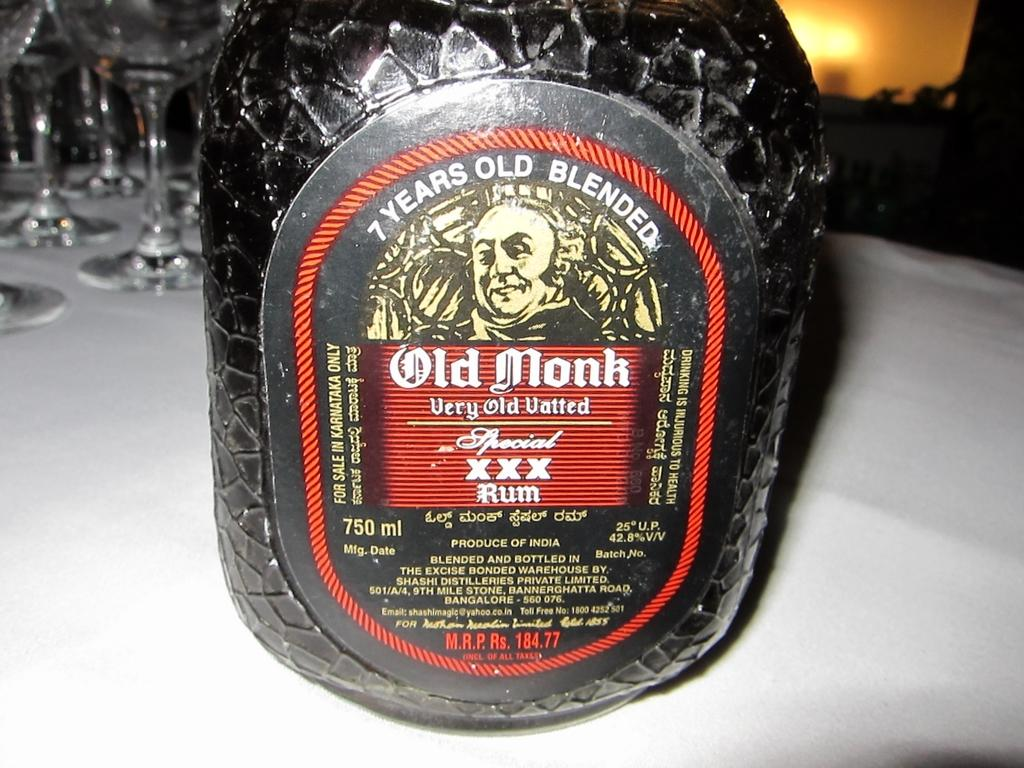What is the main object in the image? There is a rum bottle in the image. What can be seen on the rum bottle? The rum bottle has a label on it. What else is visible on the left side of the image? There are drink glasses on the left side of the image. What is located on the right side of the image? There is a light on the right side of the image. What type of invention is being demonstrated in the image? There is no invention being demonstrated in the image; it features a rum bottle, drink glasses, a label, and a light. How many legs does the rum bottle have in the image? The rum bottle is an inanimate object and does not have legs. 